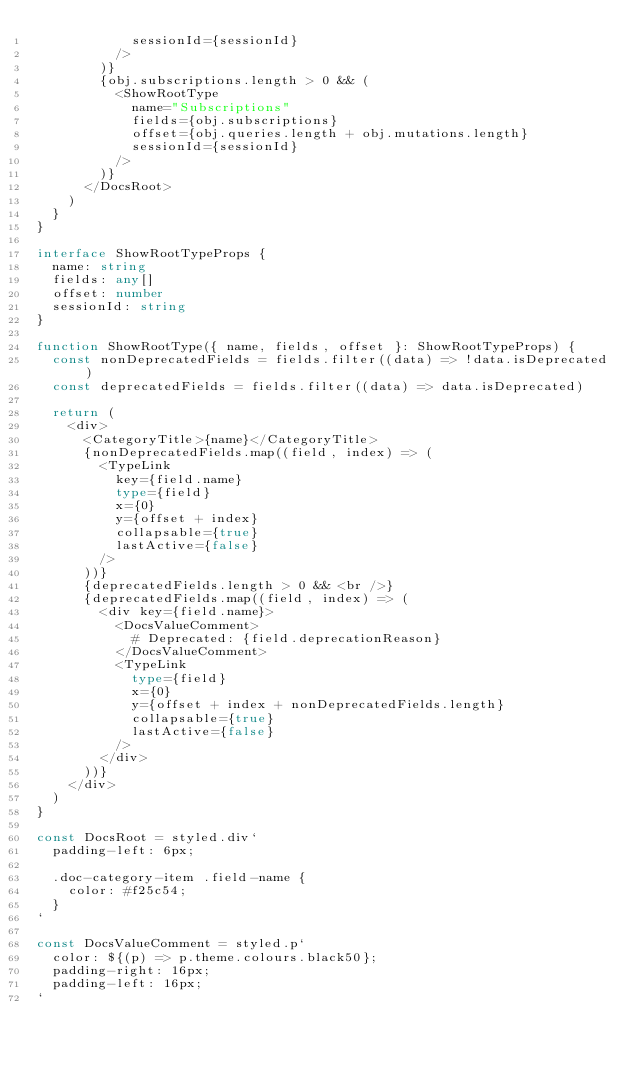Convert code to text. <code><loc_0><loc_0><loc_500><loc_500><_TypeScript_>            sessionId={sessionId}
          />
        )}
        {obj.subscriptions.length > 0 && (
          <ShowRootType
            name="Subscriptions"
            fields={obj.subscriptions}
            offset={obj.queries.length + obj.mutations.length}
            sessionId={sessionId}
          />
        )}
      </DocsRoot>
    )
  }
}

interface ShowRootTypeProps {
  name: string
  fields: any[]
  offset: number
  sessionId: string
}

function ShowRootType({ name, fields, offset }: ShowRootTypeProps) {
  const nonDeprecatedFields = fields.filter((data) => !data.isDeprecated)
  const deprecatedFields = fields.filter((data) => data.isDeprecated)

  return (
    <div>
      <CategoryTitle>{name}</CategoryTitle>
      {nonDeprecatedFields.map((field, index) => (
        <TypeLink
          key={field.name}
          type={field}
          x={0}
          y={offset + index}
          collapsable={true}
          lastActive={false}
        />
      ))}
      {deprecatedFields.length > 0 && <br />}
      {deprecatedFields.map((field, index) => (
        <div key={field.name}>
          <DocsValueComment>
            # Deprecated: {field.deprecationReason}
          </DocsValueComment>
          <TypeLink
            type={field}
            x={0}
            y={offset + index + nonDeprecatedFields.length}
            collapsable={true}
            lastActive={false}
          />
        </div>
      ))}
    </div>
  )
}

const DocsRoot = styled.div`
  padding-left: 6px;

  .doc-category-item .field-name {
    color: #f25c54;
  }
`

const DocsValueComment = styled.p`
  color: ${(p) => p.theme.colours.black50};
  padding-right: 16px;
  padding-left: 16px;
`
</code> 